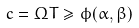Convert formula to latex. <formula><loc_0><loc_0><loc_500><loc_500>c = \Omega T \geq \phi ( \alpha , \beta )</formula> 